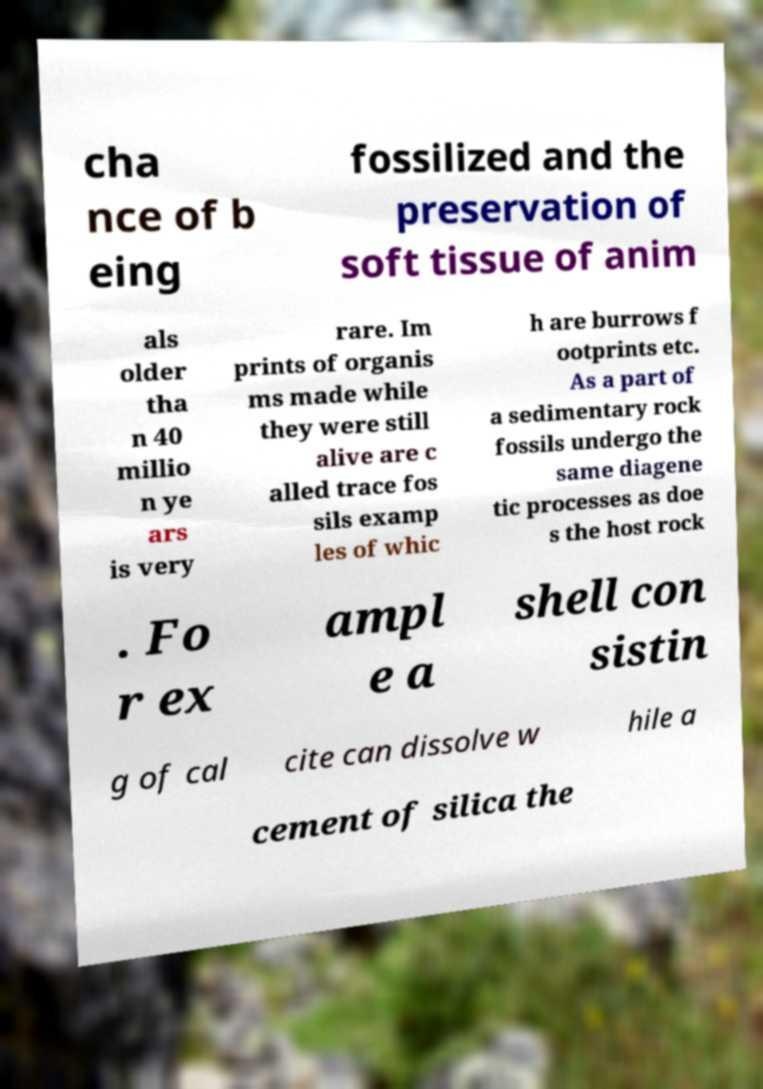Please identify and transcribe the text found in this image. cha nce of b eing fossilized and the preservation of soft tissue of anim als older tha n 40 millio n ye ars is very rare. Im prints of organis ms made while they were still alive are c alled trace fos sils examp les of whic h are burrows f ootprints etc. As a part of a sedimentary rock fossils undergo the same diagene tic processes as doe s the host rock . Fo r ex ampl e a shell con sistin g of cal cite can dissolve w hile a cement of silica the 